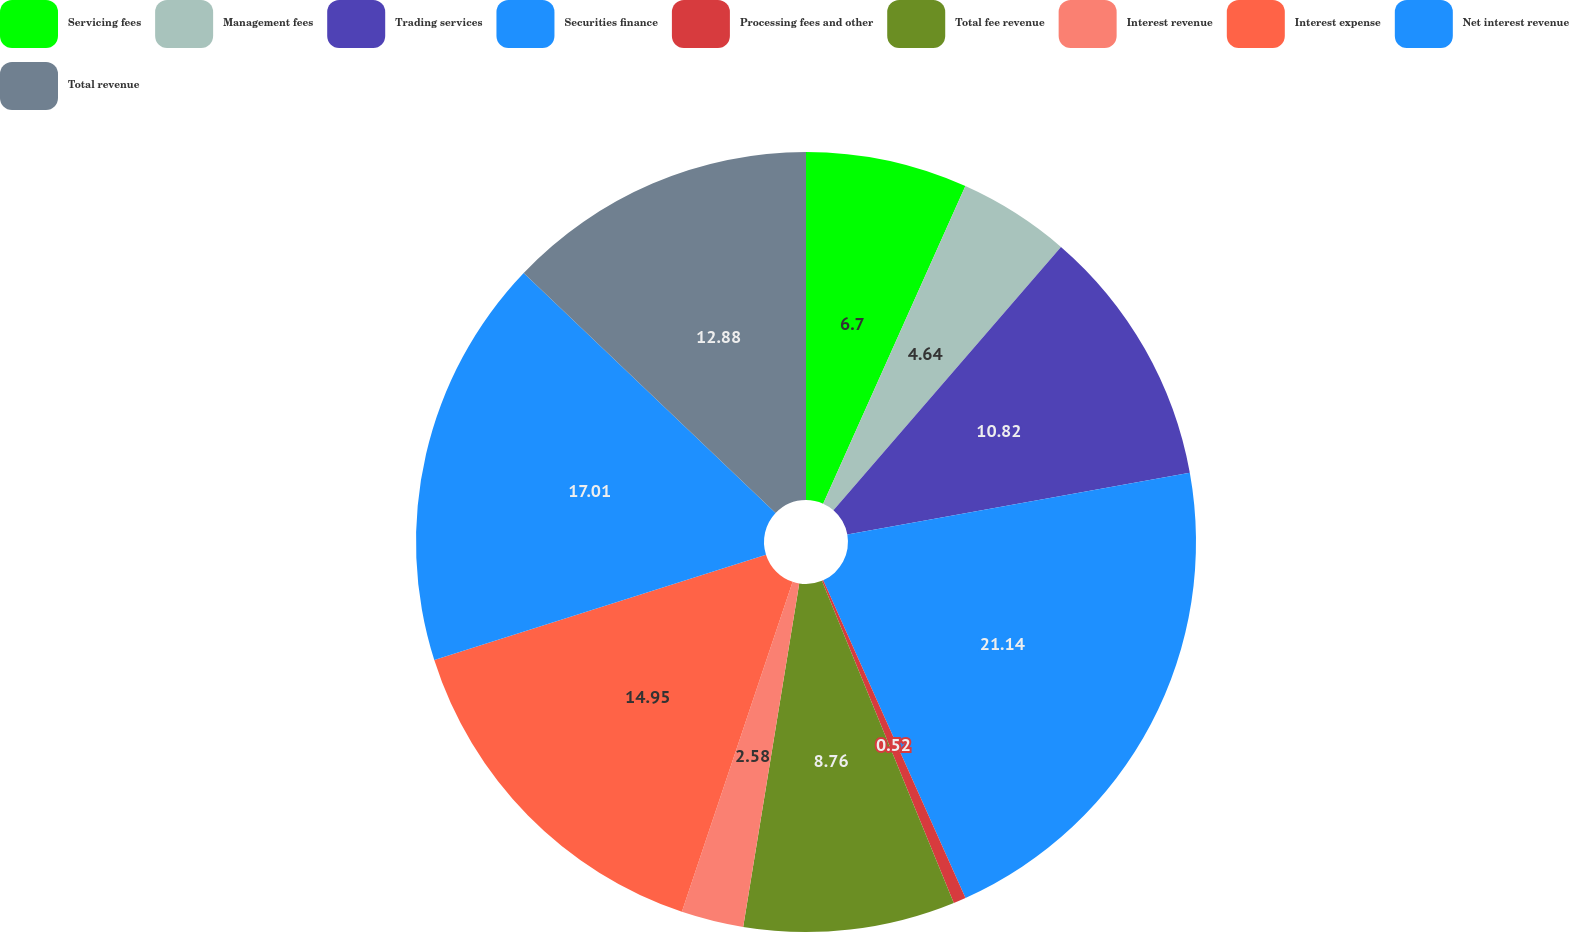Convert chart to OTSL. <chart><loc_0><loc_0><loc_500><loc_500><pie_chart><fcel>Servicing fees<fcel>Management fees<fcel>Trading services<fcel>Securities finance<fcel>Processing fees and other<fcel>Total fee revenue<fcel>Interest revenue<fcel>Interest expense<fcel>Net interest revenue<fcel>Total revenue<nl><fcel>6.7%<fcel>4.64%<fcel>10.82%<fcel>21.13%<fcel>0.52%<fcel>8.76%<fcel>2.58%<fcel>14.95%<fcel>17.01%<fcel>12.88%<nl></chart> 